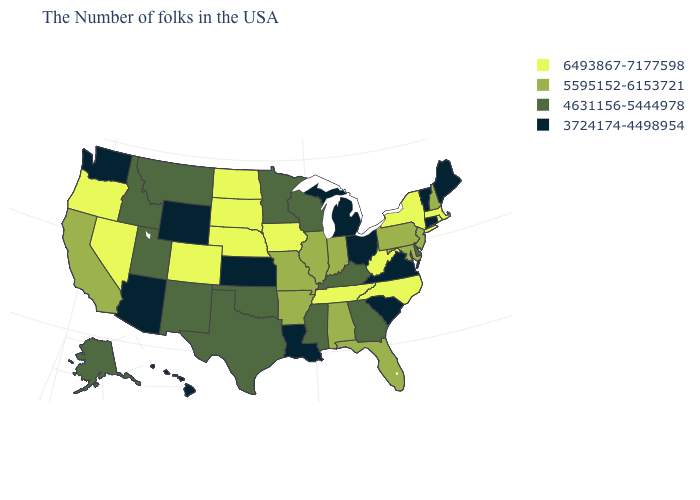Name the states that have a value in the range 4631156-5444978?
Be succinct. Delaware, Georgia, Kentucky, Wisconsin, Mississippi, Minnesota, Oklahoma, Texas, New Mexico, Utah, Montana, Idaho, Alaska. What is the value of Kentucky?
Write a very short answer. 4631156-5444978. Does the map have missing data?
Short answer required. No. Name the states that have a value in the range 4631156-5444978?
Keep it brief. Delaware, Georgia, Kentucky, Wisconsin, Mississippi, Minnesota, Oklahoma, Texas, New Mexico, Utah, Montana, Idaho, Alaska. Does Texas have the highest value in the USA?
Short answer required. No. How many symbols are there in the legend?
Concise answer only. 4. Which states hav the highest value in the South?
Write a very short answer. North Carolina, West Virginia, Tennessee. Among the states that border Washington , which have the highest value?
Concise answer only. Oregon. Does Vermont have the lowest value in the USA?
Keep it brief. Yes. Does Kentucky have a higher value than Hawaii?
Answer briefly. Yes. Among the states that border Louisiana , does Arkansas have the highest value?
Answer briefly. Yes. What is the value of Wyoming?
Give a very brief answer. 3724174-4498954. Which states have the lowest value in the USA?
Write a very short answer. Maine, Vermont, Connecticut, Virginia, South Carolina, Ohio, Michigan, Louisiana, Kansas, Wyoming, Arizona, Washington, Hawaii. Does Iowa have a lower value than Wisconsin?
Concise answer only. No. 